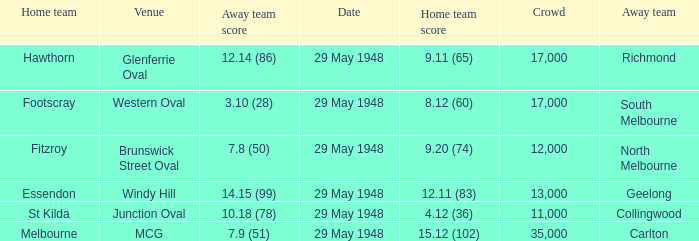During melbourne's home game, who was the away team? Carlton. 